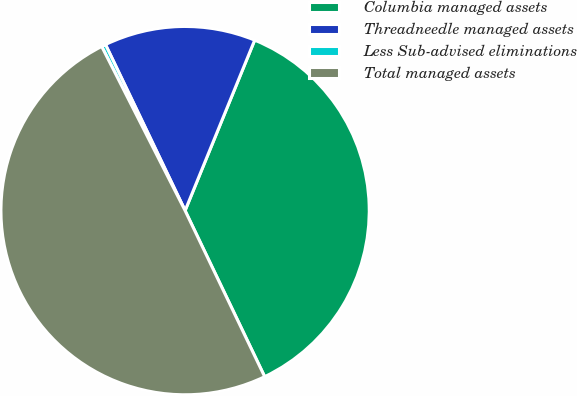Convert chart. <chart><loc_0><loc_0><loc_500><loc_500><pie_chart><fcel>Columbia managed assets<fcel>Threadneedle managed assets<fcel>Less Sub-advised eliminations<fcel>Total managed assets<nl><fcel>36.72%<fcel>13.28%<fcel>0.37%<fcel>49.63%<nl></chart> 